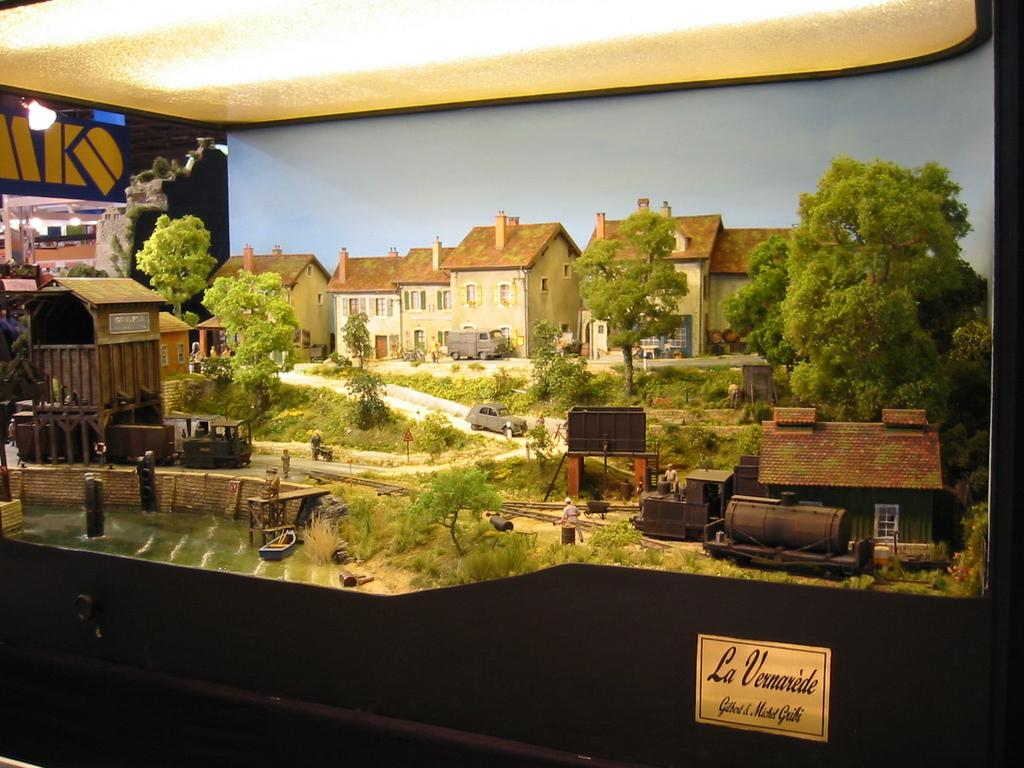<image>
Describe the image concisely. a bucolic scene with the words La Vernarede on the bottom right 